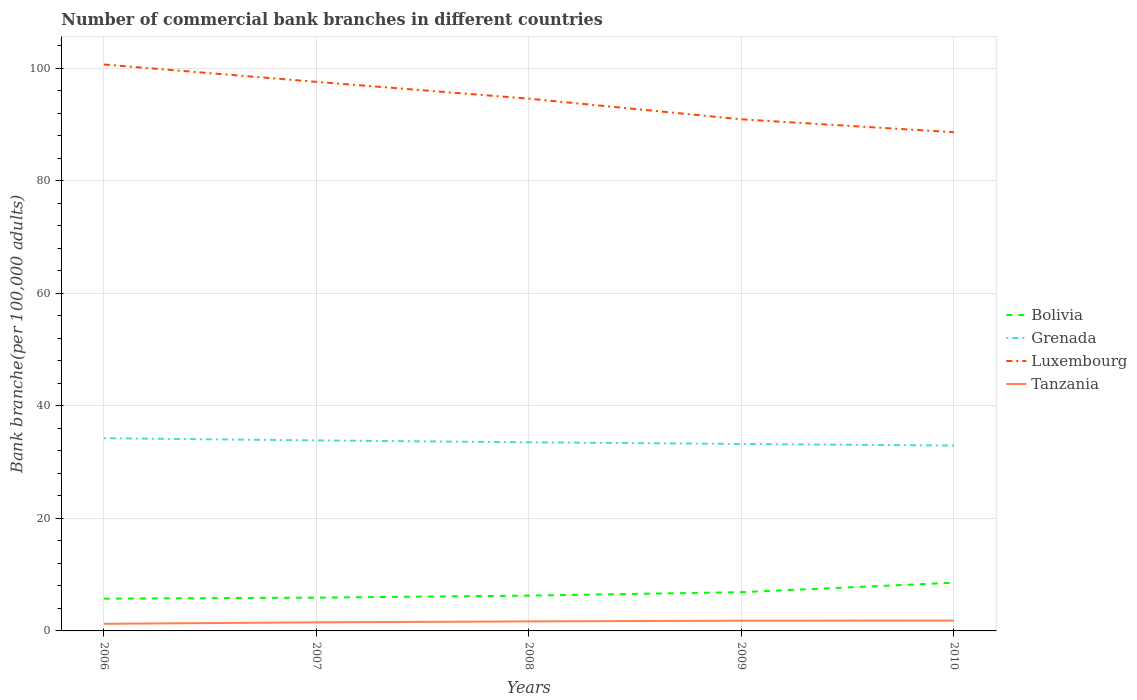How many different coloured lines are there?
Provide a short and direct response. 4. Does the line corresponding to Luxembourg intersect with the line corresponding to Tanzania?
Your response must be concise. No. Across all years, what is the maximum number of commercial bank branches in Tanzania?
Give a very brief answer. 1.27. In which year was the number of commercial bank branches in Luxembourg maximum?
Make the answer very short. 2010. What is the total number of commercial bank branches in Tanzania in the graph?
Your answer should be very brief. -0.31. What is the difference between the highest and the second highest number of commercial bank branches in Bolivia?
Provide a short and direct response. 2.84. What is the difference between the highest and the lowest number of commercial bank branches in Bolivia?
Keep it short and to the point. 2. Is the number of commercial bank branches in Tanzania strictly greater than the number of commercial bank branches in Grenada over the years?
Offer a very short reply. Yes. How many years are there in the graph?
Offer a very short reply. 5. What is the difference between two consecutive major ticks on the Y-axis?
Ensure brevity in your answer.  20. Are the values on the major ticks of Y-axis written in scientific E-notation?
Ensure brevity in your answer.  No. Does the graph contain grids?
Provide a short and direct response. Yes. How are the legend labels stacked?
Your response must be concise. Vertical. What is the title of the graph?
Provide a succinct answer. Number of commercial bank branches in different countries. What is the label or title of the Y-axis?
Make the answer very short. Bank branche(per 100,0 adults). What is the Bank branche(per 100,000 adults) of Bolivia in 2006?
Offer a very short reply. 5.74. What is the Bank branche(per 100,000 adults) in Grenada in 2006?
Your response must be concise. 34.25. What is the Bank branche(per 100,000 adults) in Luxembourg in 2006?
Offer a very short reply. 100.65. What is the Bank branche(per 100,000 adults) in Tanzania in 2006?
Your answer should be compact. 1.27. What is the Bank branche(per 100,000 adults) in Bolivia in 2007?
Offer a terse response. 5.91. What is the Bank branche(per 100,000 adults) of Grenada in 2007?
Make the answer very short. 33.86. What is the Bank branche(per 100,000 adults) of Luxembourg in 2007?
Make the answer very short. 97.57. What is the Bank branche(per 100,000 adults) in Tanzania in 2007?
Provide a succinct answer. 1.53. What is the Bank branche(per 100,000 adults) in Bolivia in 2008?
Ensure brevity in your answer.  6.28. What is the Bank branche(per 100,000 adults) in Grenada in 2008?
Keep it short and to the point. 33.52. What is the Bank branche(per 100,000 adults) of Luxembourg in 2008?
Ensure brevity in your answer.  94.59. What is the Bank branche(per 100,000 adults) of Tanzania in 2008?
Provide a short and direct response. 1.69. What is the Bank branche(per 100,000 adults) of Bolivia in 2009?
Ensure brevity in your answer.  6.89. What is the Bank branche(per 100,000 adults) in Grenada in 2009?
Make the answer very short. 33.22. What is the Bank branche(per 100,000 adults) of Luxembourg in 2009?
Offer a terse response. 90.92. What is the Bank branche(per 100,000 adults) of Tanzania in 2009?
Provide a short and direct response. 1.82. What is the Bank branche(per 100,000 adults) of Bolivia in 2010?
Ensure brevity in your answer.  8.57. What is the Bank branche(per 100,000 adults) in Grenada in 2010?
Give a very brief answer. 32.95. What is the Bank branche(per 100,000 adults) in Luxembourg in 2010?
Ensure brevity in your answer.  88.62. What is the Bank branche(per 100,000 adults) in Tanzania in 2010?
Offer a terse response. 1.83. Across all years, what is the maximum Bank branche(per 100,000 adults) in Bolivia?
Provide a short and direct response. 8.57. Across all years, what is the maximum Bank branche(per 100,000 adults) in Grenada?
Keep it short and to the point. 34.25. Across all years, what is the maximum Bank branche(per 100,000 adults) in Luxembourg?
Ensure brevity in your answer.  100.65. Across all years, what is the maximum Bank branche(per 100,000 adults) of Tanzania?
Ensure brevity in your answer.  1.83. Across all years, what is the minimum Bank branche(per 100,000 adults) of Bolivia?
Your answer should be very brief. 5.74. Across all years, what is the minimum Bank branche(per 100,000 adults) of Grenada?
Your response must be concise. 32.95. Across all years, what is the minimum Bank branche(per 100,000 adults) of Luxembourg?
Your response must be concise. 88.62. Across all years, what is the minimum Bank branche(per 100,000 adults) in Tanzania?
Offer a very short reply. 1.27. What is the total Bank branche(per 100,000 adults) in Bolivia in the graph?
Your answer should be very brief. 33.39. What is the total Bank branche(per 100,000 adults) of Grenada in the graph?
Provide a short and direct response. 167.8. What is the total Bank branche(per 100,000 adults) of Luxembourg in the graph?
Your answer should be very brief. 472.35. What is the total Bank branche(per 100,000 adults) of Tanzania in the graph?
Offer a terse response. 8.14. What is the difference between the Bank branche(per 100,000 adults) of Bolivia in 2006 and that in 2007?
Your answer should be compact. -0.18. What is the difference between the Bank branche(per 100,000 adults) of Grenada in 2006 and that in 2007?
Your response must be concise. 0.39. What is the difference between the Bank branche(per 100,000 adults) in Luxembourg in 2006 and that in 2007?
Give a very brief answer. 3.08. What is the difference between the Bank branche(per 100,000 adults) of Tanzania in 2006 and that in 2007?
Your answer should be compact. -0.26. What is the difference between the Bank branche(per 100,000 adults) of Bolivia in 2006 and that in 2008?
Keep it short and to the point. -0.54. What is the difference between the Bank branche(per 100,000 adults) in Grenada in 2006 and that in 2008?
Make the answer very short. 0.73. What is the difference between the Bank branche(per 100,000 adults) of Luxembourg in 2006 and that in 2008?
Make the answer very short. 6.06. What is the difference between the Bank branche(per 100,000 adults) in Tanzania in 2006 and that in 2008?
Offer a very short reply. -0.43. What is the difference between the Bank branche(per 100,000 adults) of Bolivia in 2006 and that in 2009?
Keep it short and to the point. -1.15. What is the difference between the Bank branche(per 100,000 adults) in Grenada in 2006 and that in 2009?
Offer a terse response. 1.02. What is the difference between the Bank branche(per 100,000 adults) in Luxembourg in 2006 and that in 2009?
Give a very brief answer. 9.73. What is the difference between the Bank branche(per 100,000 adults) of Tanzania in 2006 and that in 2009?
Provide a short and direct response. -0.55. What is the difference between the Bank branche(per 100,000 adults) of Bolivia in 2006 and that in 2010?
Your answer should be compact. -2.84. What is the difference between the Bank branche(per 100,000 adults) in Grenada in 2006 and that in 2010?
Your response must be concise. 1.3. What is the difference between the Bank branche(per 100,000 adults) in Luxembourg in 2006 and that in 2010?
Provide a succinct answer. 12.03. What is the difference between the Bank branche(per 100,000 adults) in Tanzania in 2006 and that in 2010?
Provide a succinct answer. -0.57. What is the difference between the Bank branche(per 100,000 adults) in Bolivia in 2007 and that in 2008?
Offer a very short reply. -0.36. What is the difference between the Bank branche(per 100,000 adults) in Grenada in 2007 and that in 2008?
Provide a succinct answer. 0.33. What is the difference between the Bank branche(per 100,000 adults) in Luxembourg in 2007 and that in 2008?
Make the answer very short. 2.99. What is the difference between the Bank branche(per 100,000 adults) of Tanzania in 2007 and that in 2008?
Keep it short and to the point. -0.17. What is the difference between the Bank branche(per 100,000 adults) in Bolivia in 2007 and that in 2009?
Give a very brief answer. -0.97. What is the difference between the Bank branche(per 100,000 adults) in Grenada in 2007 and that in 2009?
Provide a succinct answer. 0.63. What is the difference between the Bank branche(per 100,000 adults) in Luxembourg in 2007 and that in 2009?
Provide a succinct answer. 6.66. What is the difference between the Bank branche(per 100,000 adults) in Tanzania in 2007 and that in 2009?
Provide a short and direct response. -0.29. What is the difference between the Bank branche(per 100,000 adults) in Bolivia in 2007 and that in 2010?
Your answer should be very brief. -2.66. What is the difference between the Bank branche(per 100,000 adults) in Grenada in 2007 and that in 2010?
Keep it short and to the point. 0.91. What is the difference between the Bank branche(per 100,000 adults) of Luxembourg in 2007 and that in 2010?
Provide a short and direct response. 8.95. What is the difference between the Bank branche(per 100,000 adults) in Tanzania in 2007 and that in 2010?
Provide a short and direct response. -0.31. What is the difference between the Bank branche(per 100,000 adults) of Bolivia in 2008 and that in 2009?
Offer a very short reply. -0.61. What is the difference between the Bank branche(per 100,000 adults) in Grenada in 2008 and that in 2009?
Keep it short and to the point. 0.3. What is the difference between the Bank branche(per 100,000 adults) in Luxembourg in 2008 and that in 2009?
Keep it short and to the point. 3.67. What is the difference between the Bank branche(per 100,000 adults) in Tanzania in 2008 and that in 2009?
Provide a short and direct response. -0.13. What is the difference between the Bank branche(per 100,000 adults) in Bolivia in 2008 and that in 2010?
Ensure brevity in your answer.  -2.3. What is the difference between the Bank branche(per 100,000 adults) in Grenada in 2008 and that in 2010?
Keep it short and to the point. 0.58. What is the difference between the Bank branche(per 100,000 adults) of Luxembourg in 2008 and that in 2010?
Your answer should be compact. 5.97. What is the difference between the Bank branche(per 100,000 adults) of Tanzania in 2008 and that in 2010?
Make the answer very short. -0.14. What is the difference between the Bank branche(per 100,000 adults) of Bolivia in 2009 and that in 2010?
Give a very brief answer. -1.69. What is the difference between the Bank branche(per 100,000 adults) in Grenada in 2009 and that in 2010?
Your answer should be compact. 0.28. What is the difference between the Bank branche(per 100,000 adults) of Luxembourg in 2009 and that in 2010?
Offer a terse response. 2.29. What is the difference between the Bank branche(per 100,000 adults) in Tanzania in 2009 and that in 2010?
Offer a terse response. -0.02. What is the difference between the Bank branche(per 100,000 adults) in Bolivia in 2006 and the Bank branche(per 100,000 adults) in Grenada in 2007?
Your response must be concise. -28.12. What is the difference between the Bank branche(per 100,000 adults) in Bolivia in 2006 and the Bank branche(per 100,000 adults) in Luxembourg in 2007?
Your response must be concise. -91.84. What is the difference between the Bank branche(per 100,000 adults) in Bolivia in 2006 and the Bank branche(per 100,000 adults) in Tanzania in 2007?
Provide a succinct answer. 4.21. What is the difference between the Bank branche(per 100,000 adults) in Grenada in 2006 and the Bank branche(per 100,000 adults) in Luxembourg in 2007?
Ensure brevity in your answer.  -63.32. What is the difference between the Bank branche(per 100,000 adults) of Grenada in 2006 and the Bank branche(per 100,000 adults) of Tanzania in 2007?
Your response must be concise. 32.72. What is the difference between the Bank branche(per 100,000 adults) in Luxembourg in 2006 and the Bank branche(per 100,000 adults) in Tanzania in 2007?
Keep it short and to the point. 99.12. What is the difference between the Bank branche(per 100,000 adults) of Bolivia in 2006 and the Bank branche(per 100,000 adults) of Grenada in 2008?
Make the answer very short. -27.79. What is the difference between the Bank branche(per 100,000 adults) of Bolivia in 2006 and the Bank branche(per 100,000 adults) of Luxembourg in 2008?
Make the answer very short. -88.85. What is the difference between the Bank branche(per 100,000 adults) in Bolivia in 2006 and the Bank branche(per 100,000 adults) in Tanzania in 2008?
Your response must be concise. 4.04. What is the difference between the Bank branche(per 100,000 adults) of Grenada in 2006 and the Bank branche(per 100,000 adults) of Luxembourg in 2008?
Your response must be concise. -60.34. What is the difference between the Bank branche(per 100,000 adults) of Grenada in 2006 and the Bank branche(per 100,000 adults) of Tanzania in 2008?
Provide a short and direct response. 32.56. What is the difference between the Bank branche(per 100,000 adults) in Luxembourg in 2006 and the Bank branche(per 100,000 adults) in Tanzania in 2008?
Offer a terse response. 98.96. What is the difference between the Bank branche(per 100,000 adults) of Bolivia in 2006 and the Bank branche(per 100,000 adults) of Grenada in 2009?
Ensure brevity in your answer.  -27.49. What is the difference between the Bank branche(per 100,000 adults) of Bolivia in 2006 and the Bank branche(per 100,000 adults) of Luxembourg in 2009?
Offer a terse response. -85.18. What is the difference between the Bank branche(per 100,000 adults) in Bolivia in 2006 and the Bank branche(per 100,000 adults) in Tanzania in 2009?
Ensure brevity in your answer.  3.92. What is the difference between the Bank branche(per 100,000 adults) of Grenada in 2006 and the Bank branche(per 100,000 adults) of Luxembourg in 2009?
Make the answer very short. -56.67. What is the difference between the Bank branche(per 100,000 adults) of Grenada in 2006 and the Bank branche(per 100,000 adults) of Tanzania in 2009?
Your response must be concise. 32.43. What is the difference between the Bank branche(per 100,000 adults) of Luxembourg in 2006 and the Bank branche(per 100,000 adults) of Tanzania in 2009?
Make the answer very short. 98.83. What is the difference between the Bank branche(per 100,000 adults) of Bolivia in 2006 and the Bank branche(per 100,000 adults) of Grenada in 2010?
Your answer should be compact. -27.21. What is the difference between the Bank branche(per 100,000 adults) of Bolivia in 2006 and the Bank branche(per 100,000 adults) of Luxembourg in 2010?
Your answer should be very brief. -82.89. What is the difference between the Bank branche(per 100,000 adults) of Bolivia in 2006 and the Bank branche(per 100,000 adults) of Tanzania in 2010?
Your response must be concise. 3.9. What is the difference between the Bank branche(per 100,000 adults) of Grenada in 2006 and the Bank branche(per 100,000 adults) of Luxembourg in 2010?
Offer a very short reply. -54.37. What is the difference between the Bank branche(per 100,000 adults) in Grenada in 2006 and the Bank branche(per 100,000 adults) in Tanzania in 2010?
Your answer should be very brief. 32.41. What is the difference between the Bank branche(per 100,000 adults) in Luxembourg in 2006 and the Bank branche(per 100,000 adults) in Tanzania in 2010?
Provide a succinct answer. 98.82. What is the difference between the Bank branche(per 100,000 adults) in Bolivia in 2007 and the Bank branche(per 100,000 adults) in Grenada in 2008?
Provide a short and direct response. -27.61. What is the difference between the Bank branche(per 100,000 adults) in Bolivia in 2007 and the Bank branche(per 100,000 adults) in Luxembourg in 2008?
Your response must be concise. -88.67. What is the difference between the Bank branche(per 100,000 adults) of Bolivia in 2007 and the Bank branche(per 100,000 adults) of Tanzania in 2008?
Provide a succinct answer. 4.22. What is the difference between the Bank branche(per 100,000 adults) in Grenada in 2007 and the Bank branche(per 100,000 adults) in Luxembourg in 2008?
Offer a terse response. -60.73. What is the difference between the Bank branche(per 100,000 adults) in Grenada in 2007 and the Bank branche(per 100,000 adults) in Tanzania in 2008?
Provide a short and direct response. 32.16. What is the difference between the Bank branche(per 100,000 adults) in Luxembourg in 2007 and the Bank branche(per 100,000 adults) in Tanzania in 2008?
Provide a short and direct response. 95.88. What is the difference between the Bank branche(per 100,000 adults) of Bolivia in 2007 and the Bank branche(per 100,000 adults) of Grenada in 2009?
Make the answer very short. -27.31. What is the difference between the Bank branche(per 100,000 adults) in Bolivia in 2007 and the Bank branche(per 100,000 adults) in Luxembourg in 2009?
Keep it short and to the point. -85. What is the difference between the Bank branche(per 100,000 adults) in Bolivia in 2007 and the Bank branche(per 100,000 adults) in Tanzania in 2009?
Your response must be concise. 4.1. What is the difference between the Bank branche(per 100,000 adults) of Grenada in 2007 and the Bank branche(per 100,000 adults) of Luxembourg in 2009?
Offer a very short reply. -57.06. What is the difference between the Bank branche(per 100,000 adults) in Grenada in 2007 and the Bank branche(per 100,000 adults) in Tanzania in 2009?
Ensure brevity in your answer.  32.04. What is the difference between the Bank branche(per 100,000 adults) of Luxembourg in 2007 and the Bank branche(per 100,000 adults) of Tanzania in 2009?
Keep it short and to the point. 95.75. What is the difference between the Bank branche(per 100,000 adults) of Bolivia in 2007 and the Bank branche(per 100,000 adults) of Grenada in 2010?
Make the answer very short. -27.03. What is the difference between the Bank branche(per 100,000 adults) in Bolivia in 2007 and the Bank branche(per 100,000 adults) in Luxembourg in 2010?
Your answer should be very brief. -82.71. What is the difference between the Bank branche(per 100,000 adults) of Bolivia in 2007 and the Bank branche(per 100,000 adults) of Tanzania in 2010?
Ensure brevity in your answer.  4.08. What is the difference between the Bank branche(per 100,000 adults) in Grenada in 2007 and the Bank branche(per 100,000 adults) in Luxembourg in 2010?
Provide a succinct answer. -54.77. What is the difference between the Bank branche(per 100,000 adults) in Grenada in 2007 and the Bank branche(per 100,000 adults) in Tanzania in 2010?
Provide a short and direct response. 32.02. What is the difference between the Bank branche(per 100,000 adults) in Luxembourg in 2007 and the Bank branche(per 100,000 adults) in Tanzania in 2010?
Give a very brief answer. 95.74. What is the difference between the Bank branche(per 100,000 adults) in Bolivia in 2008 and the Bank branche(per 100,000 adults) in Grenada in 2009?
Your response must be concise. -26.95. What is the difference between the Bank branche(per 100,000 adults) in Bolivia in 2008 and the Bank branche(per 100,000 adults) in Luxembourg in 2009?
Keep it short and to the point. -84.64. What is the difference between the Bank branche(per 100,000 adults) of Bolivia in 2008 and the Bank branche(per 100,000 adults) of Tanzania in 2009?
Your answer should be compact. 4.46. What is the difference between the Bank branche(per 100,000 adults) in Grenada in 2008 and the Bank branche(per 100,000 adults) in Luxembourg in 2009?
Provide a succinct answer. -57.39. What is the difference between the Bank branche(per 100,000 adults) in Grenada in 2008 and the Bank branche(per 100,000 adults) in Tanzania in 2009?
Ensure brevity in your answer.  31.7. What is the difference between the Bank branche(per 100,000 adults) in Luxembourg in 2008 and the Bank branche(per 100,000 adults) in Tanzania in 2009?
Offer a terse response. 92.77. What is the difference between the Bank branche(per 100,000 adults) of Bolivia in 2008 and the Bank branche(per 100,000 adults) of Grenada in 2010?
Your answer should be very brief. -26.67. What is the difference between the Bank branche(per 100,000 adults) in Bolivia in 2008 and the Bank branche(per 100,000 adults) in Luxembourg in 2010?
Keep it short and to the point. -82.35. What is the difference between the Bank branche(per 100,000 adults) of Bolivia in 2008 and the Bank branche(per 100,000 adults) of Tanzania in 2010?
Give a very brief answer. 4.44. What is the difference between the Bank branche(per 100,000 adults) of Grenada in 2008 and the Bank branche(per 100,000 adults) of Luxembourg in 2010?
Make the answer very short. -55.1. What is the difference between the Bank branche(per 100,000 adults) of Grenada in 2008 and the Bank branche(per 100,000 adults) of Tanzania in 2010?
Your response must be concise. 31.69. What is the difference between the Bank branche(per 100,000 adults) of Luxembourg in 2008 and the Bank branche(per 100,000 adults) of Tanzania in 2010?
Provide a short and direct response. 92.75. What is the difference between the Bank branche(per 100,000 adults) in Bolivia in 2009 and the Bank branche(per 100,000 adults) in Grenada in 2010?
Keep it short and to the point. -26.06. What is the difference between the Bank branche(per 100,000 adults) of Bolivia in 2009 and the Bank branche(per 100,000 adults) of Luxembourg in 2010?
Keep it short and to the point. -81.74. What is the difference between the Bank branche(per 100,000 adults) of Bolivia in 2009 and the Bank branche(per 100,000 adults) of Tanzania in 2010?
Your answer should be very brief. 5.05. What is the difference between the Bank branche(per 100,000 adults) in Grenada in 2009 and the Bank branche(per 100,000 adults) in Luxembourg in 2010?
Give a very brief answer. -55.4. What is the difference between the Bank branche(per 100,000 adults) in Grenada in 2009 and the Bank branche(per 100,000 adults) in Tanzania in 2010?
Provide a short and direct response. 31.39. What is the difference between the Bank branche(per 100,000 adults) in Luxembourg in 2009 and the Bank branche(per 100,000 adults) in Tanzania in 2010?
Your answer should be compact. 89.08. What is the average Bank branche(per 100,000 adults) of Bolivia per year?
Ensure brevity in your answer.  6.68. What is the average Bank branche(per 100,000 adults) in Grenada per year?
Make the answer very short. 33.56. What is the average Bank branche(per 100,000 adults) in Luxembourg per year?
Provide a short and direct response. 94.47. What is the average Bank branche(per 100,000 adults) of Tanzania per year?
Provide a succinct answer. 1.63. In the year 2006, what is the difference between the Bank branche(per 100,000 adults) of Bolivia and Bank branche(per 100,000 adults) of Grenada?
Offer a very short reply. -28.51. In the year 2006, what is the difference between the Bank branche(per 100,000 adults) of Bolivia and Bank branche(per 100,000 adults) of Luxembourg?
Offer a terse response. -94.91. In the year 2006, what is the difference between the Bank branche(per 100,000 adults) of Bolivia and Bank branche(per 100,000 adults) of Tanzania?
Give a very brief answer. 4.47. In the year 2006, what is the difference between the Bank branche(per 100,000 adults) of Grenada and Bank branche(per 100,000 adults) of Luxembourg?
Provide a succinct answer. -66.4. In the year 2006, what is the difference between the Bank branche(per 100,000 adults) of Grenada and Bank branche(per 100,000 adults) of Tanzania?
Keep it short and to the point. 32.98. In the year 2006, what is the difference between the Bank branche(per 100,000 adults) of Luxembourg and Bank branche(per 100,000 adults) of Tanzania?
Your answer should be compact. 99.38. In the year 2007, what is the difference between the Bank branche(per 100,000 adults) in Bolivia and Bank branche(per 100,000 adults) in Grenada?
Provide a succinct answer. -27.94. In the year 2007, what is the difference between the Bank branche(per 100,000 adults) of Bolivia and Bank branche(per 100,000 adults) of Luxembourg?
Offer a terse response. -91.66. In the year 2007, what is the difference between the Bank branche(per 100,000 adults) in Bolivia and Bank branche(per 100,000 adults) in Tanzania?
Your answer should be compact. 4.39. In the year 2007, what is the difference between the Bank branche(per 100,000 adults) of Grenada and Bank branche(per 100,000 adults) of Luxembourg?
Provide a short and direct response. -63.72. In the year 2007, what is the difference between the Bank branche(per 100,000 adults) of Grenada and Bank branche(per 100,000 adults) of Tanzania?
Give a very brief answer. 32.33. In the year 2007, what is the difference between the Bank branche(per 100,000 adults) in Luxembourg and Bank branche(per 100,000 adults) in Tanzania?
Provide a short and direct response. 96.05. In the year 2008, what is the difference between the Bank branche(per 100,000 adults) in Bolivia and Bank branche(per 100,000 adults) in Grenada?
Make the answer very short. -27.25. In the year 2008, what is the difference between the Bank branche(per 100,000 adults) in Bolivia and Bank branche(per 100,000 adults) in Luxembourg?
Your answer should be very brief. -88.31. In the year 2008, what is the difference between the Bank branche(per 100,000 adults) of Bolivia and Bank branche(per 100,000 adults) of Tanzania?
Offer a very short reply. 4.58. In the year 2008, what is the difference between the Bank branche(per 100,000 adults) in Grenada and Bank branche(per 100,000 adults) in Luxembourg?
Your answer should be very brief. -61.06. In the year 2008, what is the difference between the Bank branche(per 100,000 adults) of Grenada and Bank branche(per 100,000 adults) of Tanzania?
Your answer should be compact. 31.83. In the year 2008, what is the difference between the Bank branche(per 100,000 adults) of Luxembourg and Bank branche(per 100,000 adults) of Tanzania?
Keep it short and to the point. 92.89. In the year 2009, what is the difference between the Bank branche(per 100,000 adults) of Bolivia and Bank branche(per 100,000 adults) of Grenada?
Ensure brevity in your answer.  -26.34. In the year 2009, what is the difference between the Bank branche(per 100,000 adults) in Bolivia and Bank branche(per 100,000 adults) in Luxembourg?
Your answer should be compact. -84.03. In the year 2009, what is the difference between the Bank branche(per 100,000 adults) in Bolivia and Bank branche(per 100,000 adults) in Tanzania?
Your answer should be very brief. 5.07. In the year 2009, what is the difference between the Bank branche(per 100,000 adults) in Grenada and Bank branche(per 100,000 adults) in Luxembourg?
Provide a succinct answer. -57.69. In the year 2009, what is the difference between the Bank branche(per 100,000 adults) in Grenada and Bank branche(per 100,000 adults) in Tanzania?
Your answer should be very brief. 31.41. In the year 2009, what is the difference between the Bank branche(per 100,000 adults) in Luxembourg and Bank branche(per 100,000 adults) in Tanzania?
Keep it short and to the point. 89.1. In the year 2010, what is the difference between the Bank branche(per 100,000 adults) in Bolivia and Bank branche(per 100,000 adults) in Grenada?
Offer a very short reply. -24.37. In the year 2010, what is the difference between the Bank branche(per 100,000 adults) of Bolivia and Bank branche(per 100,000 adults) of Luxembourg?
Your answer should be very brief. -80.05. In the year 2010, what is the difference between the Bank branche(per 100,000 adults) of Bolivia and Bank branche(per 100,000 adults) of Tanzania?
Give a very brief answer. 6.74. In the year 2010, what is the difference between the Bank branche(per 100,000 adults) in Grenada and Bank branche(per 100,000 adults) in Luxembourg?
Offer a very short reply. -55.67. In the year 2010, what is the difference between the Bank branche(per 100,000 adults) of Grenada and Bank branche(per 100,000 adults) of Tanzania?
Give a very brief answer. 31.11. In the year 2010, what is the difference between the Bank branche(per 100,000 adults) of Luxembourg and Bank branche(per 100,000 adults) of Tanzania?
Provide a short and direct response. 86.79. What is the ratio of the Bank branche(per 100,000 adults) of Bolivia in 2006 to that in 2007?
Provide a succinct answer. 0.97. What is the ratio of the Bank branche(per 100,000 adults) of Grenada in 2006 to that in 2007?
Offer a terse response. 1.01. What is the ratio of the Bank branche(per 100,000 adults) in Luxembourg in 2006 to that in 2007?
Offer a terse response. 1.03. What is the ratio of the Bank branche(per 100,000 adults) of Tanzania in 2006 to that in 2007?
Give a very brief answer. 0.83. What is the ratio of the Bank branche(per 100,000 adults) in Bolivia in 2006 to that in 2008?
Offer a terse response. 0.91. What is the ratio of the Bank branche(per 100,000 adults) in Grenada in 2006 to that in 2008?
Offer a terse response. 1.02. What is the ratio of the Bank branche(per 100,000 adults) in Luxembourg in 2006 to that in 2008?
Your response must be concise. 1.06. What is the ratio of the Bank branche(per 100,000 adults) of Tanzania in 2006 to that in 2008?
Provide a succinct answer. 0.75. What is the ratio of the Bank branche(per 100,000 adults) in Bolivia in 2006 to that in 2009?
Offer a very short reply. 0.83. What is the ratio of the Bank branche(per 100,000 adults) in Grenada in 2006 to that in 2009?
Offer a terse response. 1.03. What is the ratio of the Bank branche(per 100,000 adults) of Luxembourg in 2006 to that in 2009?
Provide a short and direct response. 1.11. What is the ratio of the Bank branche(per 100,000 adults) of Tanzania in 2006 to that in 2009?
Your response must be concise. 0.7. What is the ratio of the Bank branche(per 100,000 adults) of Bolivia in 2006 to that in 2010?
Offer a very short reply. 0.67. What is the ratio of the Bank branche(per 100,000 adults) in Grenada in 2006 to that in 2010?
Ensure brevity in your answer.  1.04. What is the ratio of the Bank branche(per 100,000 adults) in Luxembourg in 2006 to that in 2010?
Provide a succinct answer. 1.14. What is the ratio of the Bank branche(per 100,000 adults) of Tanzania in 2006 to that in 2010?
Your answer should be compact. 0.69. What is the ratio of the Bank branche(per 100,000 adults) of Bolivia in 2007 to that in 2008?
Offer a terse response. 0.94. What is the ratio of the Bank branche(per 100,000 adults) of Grenada in 2007 to that in 2008?
Offer a very short reply. 1.01. What is the ratio of the Bank branche(per 100,000 adults) of Luxembourg in 2007 to that in 2008?
Your answer should be very brief. 1.03. What is the ratio of the Bank branche(per 100,000 adults) of Tanzania in 2007 to that in 2008?
Offer a very short reply. 0.9. What is the ratio of the Bank branche(per 100,000 adults) in Bolivia in 2007 to that in 2009?
Make the answer very short. 0.86. What is the ratio of the Bank branche(per 100,000 adults) of Luxembourg in 2007 to that in 2009?
Give a very brief answer. 1.07. What is the ratio of the Bank branche(per 100,000 adults) in Tanzania in 2007 to that in 2009?
Provide a succinct answer. 0.84. What is the ratio of the Bank branche(per 100,000 adults) in Bolivia in 2007 to that in 2010?
Make the answer very short. 0.69. What is the ratio of the Bank branche(per 100,000 adults) of Grenada in 2007 to that in 2010?
Your response must be concise. 1.03. What is the ratio of the Bank branche(per 100,000 adults) in Luxembourg in 2007 to that in 2010?
Make the answer very short. 1.1. What is the ratio of the Bank branche(per 100,000 adults) in Tanzania in 2007 to that in 2010?
Your answer should be compact. 0.83. What is the ratio of the Bank branche(per 100,000 adults) of Bolivia in 2008 to that in 2009?
Make the answer very short. 0.91. What is the ratio of the Bank branche(per 100,000 adults) of Luxembourg in 2008 to that in 2009?
Offer a very short reply. 1.04. What is the ratio of the Bank branche(per 100,000 adults) of Tanzania in 2008 to that in 2009?
Provide a succinct answer. 0.93. What is the ratio of the Bank branche(per 100,000 adults) in Bolivia in 2008 to that in 2010?
Provide a succinct answer. 0.73. What is the ratio of the Bank branche(per 100,000 adults) of Grenada in 2008 to that in 2010?
Provide a short and direct response. 1.02. What is the ratio of the Bank branche(per 100,000 adults) in Luxembourg in 2008 to that in 2010?
Your answer should be very brief. 1.07. What is the ratio of the Bank branche(per 100,000 adults) of Tanzania in 2008 to that in 2010?
Make the answer very short. 0.92. What is the ratio of the Bank branche(per 100,000 adults) of Bolivia in 2009 to that in 2010?
Make the answer very short. 0.8. What is the ratio of the Bank branche(per 100,000 adults) in Grenada in 2009 to that in 2010?
Your response must be concise. 1.01. What is the ratio of the Bank branche(per 100,000 adults) in Luxembourg in 2009 to that in 2010?
Make the answer very short. 1.03. What is the difference between the highest and the second highest Bank branche(per 100,000 adults) of Bolivia?
Your response must be concise. 1.69. What is the difference between the highest and the second highest Bank branche(per 100,000 adults) in Grenada?
Ensure brevity in your answer.  0.39. What is the difference between the highest and the second highest Bank branche(per 100,000 adults) in Luxembourg?
Make the answer very short. 3.08. What is the difference between the highest and the second highest Bank branche(per 100,000 adults) in Tanzania?
Make the answer very short. 0.02. What is the difference between the highest and the lowest Bank branche(per 100,000 adults) of Bolivia?
Provide a short and direct response. 2.84. What is the difference between the highest and the lowest Bank branche(per 100,000 adults) in Grenada?
Provide a succinct answer. 1.3. What is the difference between the highest and the lowest Bank branche(per 100,000 adults) of Luxembourg?
Offer a terse response. 12.03. What is the difference between the highest and the lowest Bank branche(per 100,000 adults) of Tanzania?
Your answer should be very brief. 0.57. 